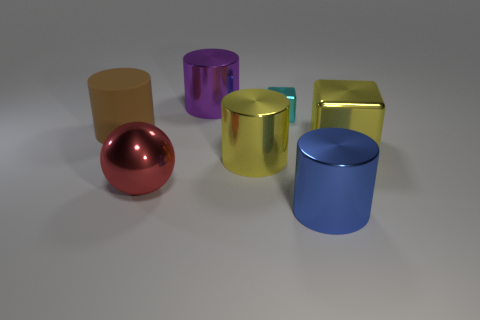Subtract all cyan cylinders. Subtract all blue cubes. How many cylinders are left? 4 Add 1 small purple matte spheres. How many objects exist? 8 Subtract all blocks. How many objects are left? 5 Subtract 0 cyan cylinders. How many objects are left? 7 Subtract all small metal blocks. Subtract all rubber things. How many objects are left? 5 Add 2 cyan objects. How many cyan objects are left? 3 Add 4 tiny cubes. How many tiny cubes exist? 5 